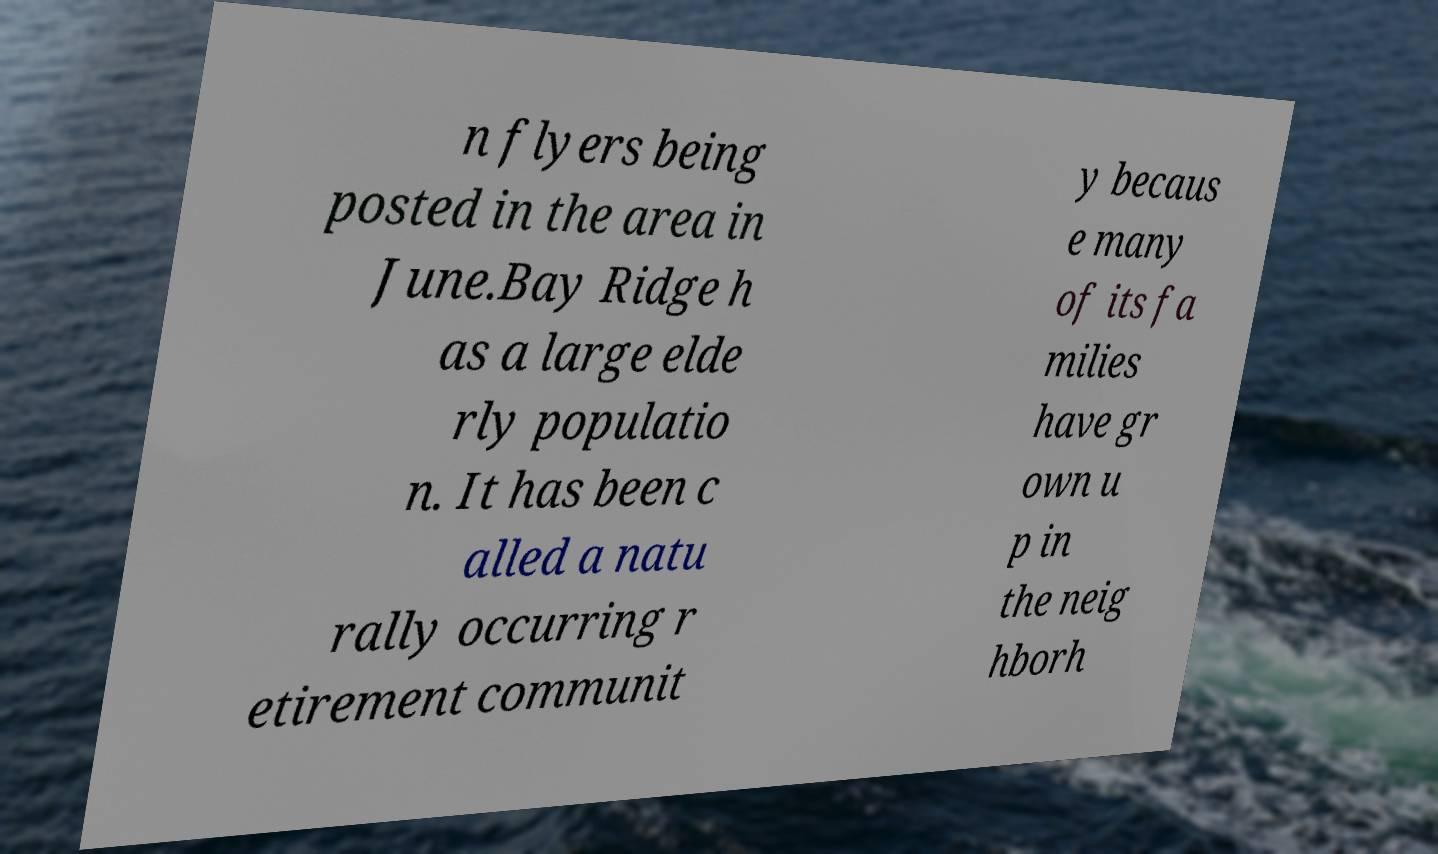Could you assist in decoding the text presented in this image and type it out clearly? n flyers being posted in the area in June.Bay Ridge h as a large elde rly populatio n. It has been c alled a natu rally occurring r etirement communit y becaus e many of its fa milies have gr own u p in the neig hborh 